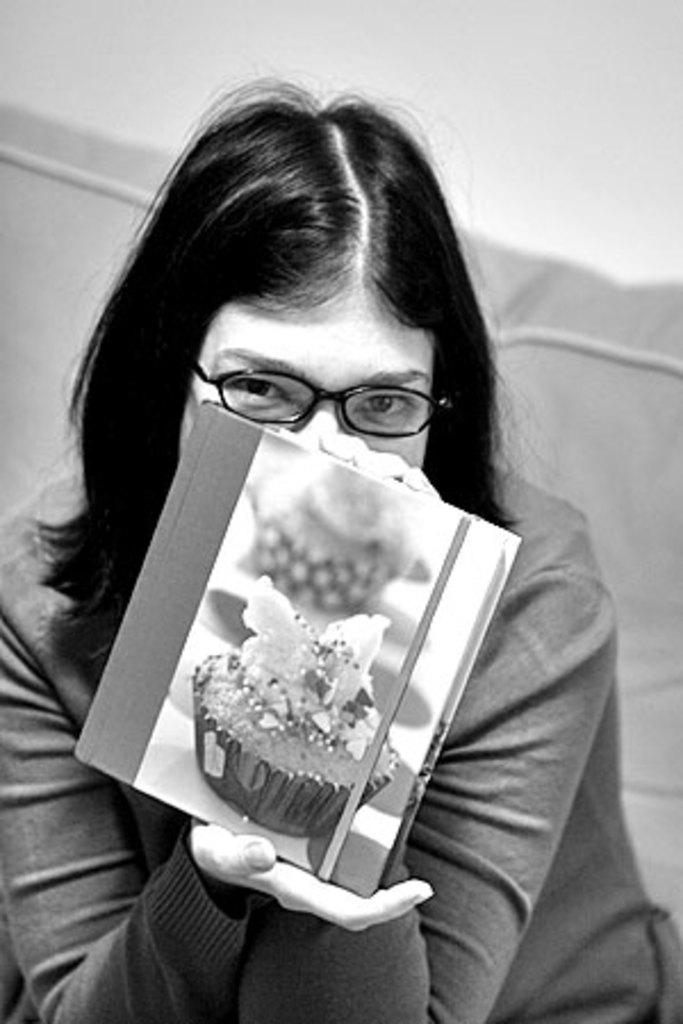What type of picture is in the image? The image contains a black and white picture of a woman. What is the woman wearing on her face? The woman is wearing glasses. What type of clothing is the woman wearing? The woman is wearing a dress. What is the woman holding in her hand? The woman is holding a book in her hand. What color is the background of the image? The background of the image is white. What type of canvas is the woman painting on in the image? There is no canvas or painting activity present in the image. What type of tank is visible in the background of the image? There is no tank visible in the background of the image; the background is white. 